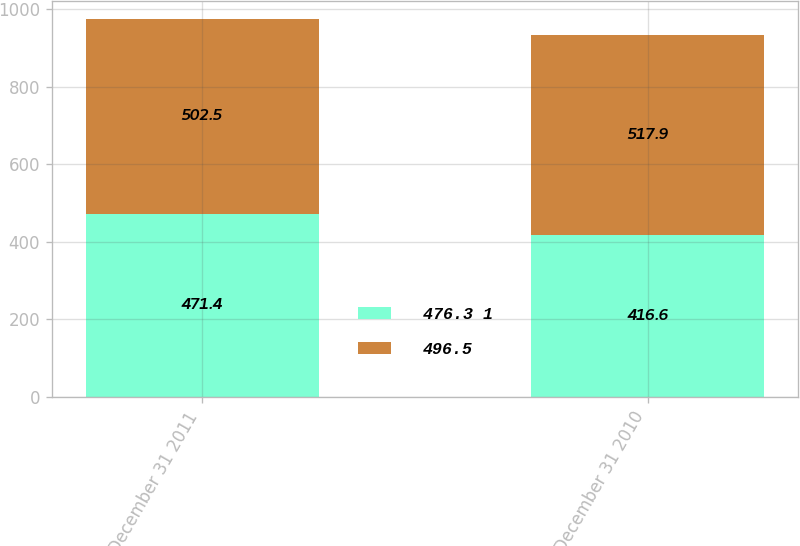Convert chart. <chart><loc_0><loc_0><loc_500><loc_500><stacked_bar_chart><ecel><fcel>December 31 2011<fcel>December 31 2010<nl><fcel>476.3 1<fcel>471.4<fcel>416.6<nl><fcel>496.5<fcel>502.5<fcel>517.9<nl></chart> 